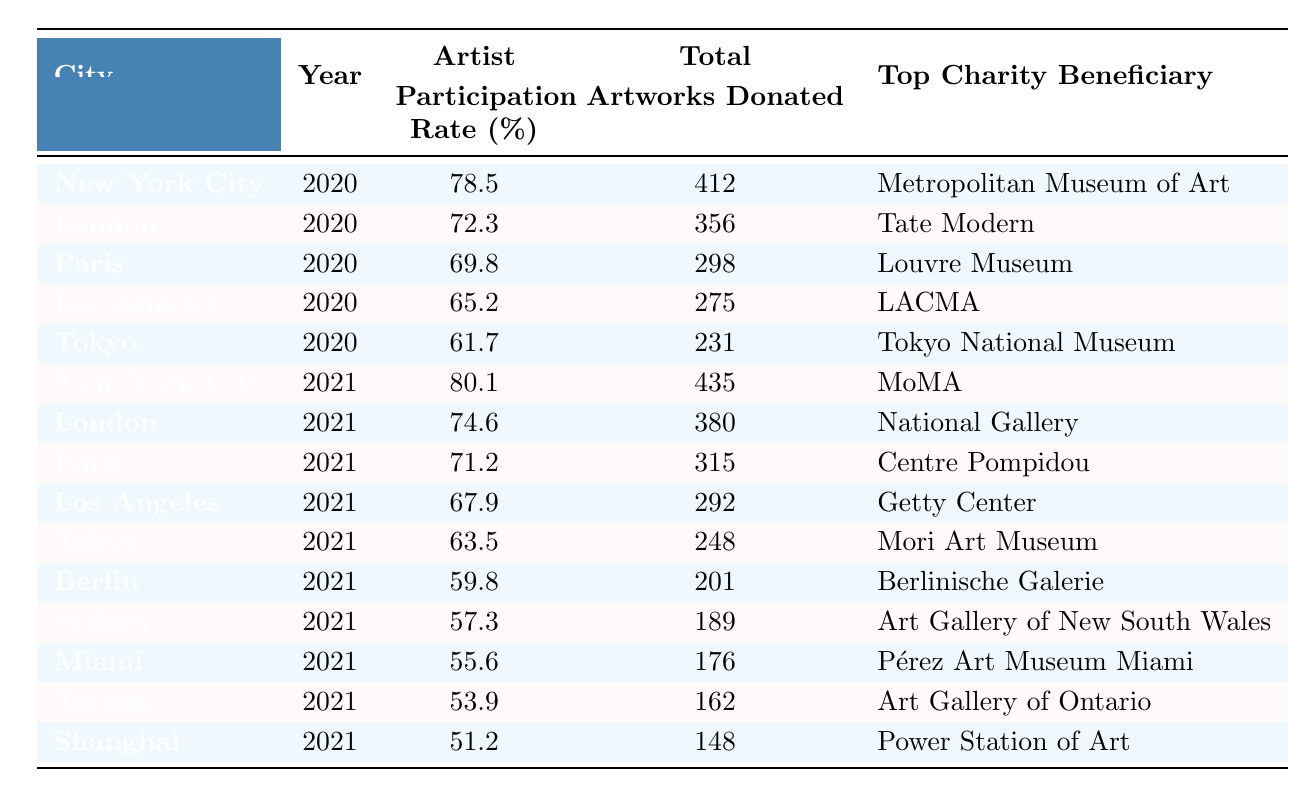What city had the highest artist participation rate in 2020? According to the table, New York City had the highest artist participation rate at 78.5% in 2020.
Answer: New York City What was the total number of artworks donated in Paris in 2021? The table shows that a total of 315 artworks were donated in Paris in 2021.
Answer: 315 Which city had the lowest artist participation rate in 2021? Looking at the data for 2021, Shanghai had the lowest artist participation rate at 51.2%.
Answer: Shanghai What was the increase in artist participation rate for New York City from 2020 to 2021? The participation rate for New York City in 2020 was 78.5% and in 2021 it was 80.1%. The increase is calculated as 80.1 - 78.5 = 1.6.
Answer: 1.6 Which city had the least number of artworks donated in 2021? From the table, Shanghai had the least number of artworks donated in 2021 with a total of 148.
Answer: Shanghai What is the average artist participation rate across all cities for the year 2020? The participation rates for 2020 are: 78.5, 72.3, 69.8, 65.2, and 61.7. The average is calculated as (78.5 + 72.3 + 69.8 + 65.2 + 61.7) / 5 = 69.13.
Answer: 69.13 Did any city have an artist participation rate above 75% in both years? By examining the table, New York City is the only city that had participation rates of 78.5% in 2020 and 80.1% in 2021, both above 75%.
Answer: Yes How does the total number of artworks donated in Tokyo compare between 2020 and 2021? The table shows that Tokyo had 231 artworks donated in 2020 and 248 in 2021. The difference is 248 - 231 = 17, indicating an increase in donations.
Answer: Increased by 17 What is the total number of artworks donated across all cities in 2021? The total artworks donated for 2021 are: 435 (NYC) + 380 (London) + 315 (Paris) + 292 (Los Angeles) + 248 (Tokyo) + 201 (Berlin) + 189 (Sydney) + 176 (Miami) + 162 (Toronto) + 148 (Shanghai) = 2266.
Answer: 2266 Which city had the top charity beneficiary as "MoMA"? The table indicates that New York City had "MoMA" as the top charity beneficiary in 2021.
Answer: New York City 